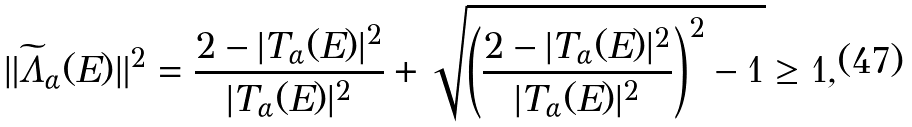Convert formula to latex. <formula><loc_0><loc_0><loc_500><loc_500>\| \widetilde { \Lambda } _ { \alpha } ( E ) \| ^ { 2 } = \frac { 2 - | T _ { \alpha } ( E ) | ^ { 2 } } { | T _ { \alpha } ( E ) | ^ { 2 } } + \sqrt { \left ( \frac { 2 - | T _ { \alpha } ( E ) | ^ { 2 } } { | T _ { \alpha } ( E ) | ^ { 2 } } \right ) ^ { 2 } - 1 } \geq 1 ,</formula> 